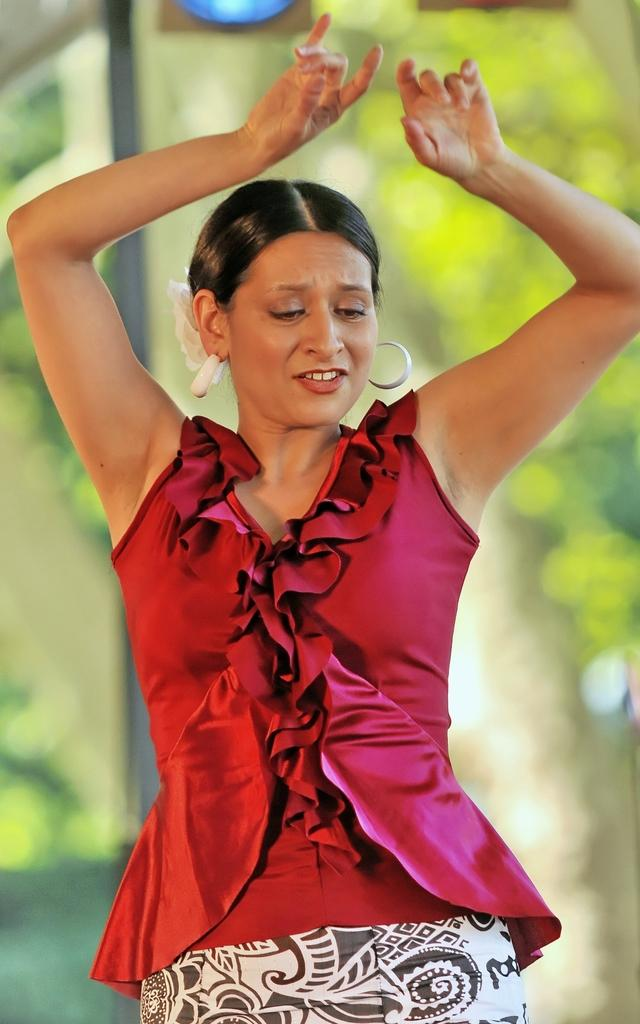What is the main subject of the image? The main subject of the image is a woman. What is the woman doing in the image? The woman is dancing in the image. What color is the top that the woman is wearing? The woman is wearing a red color top. What is the color pattern of the frock that the woman is wearing? The woman is wearing a black and white frock. What type of meat can be seen in the woman's hand in the image? There is no meat present in the image; the woman is dancing and not holding any food items. 